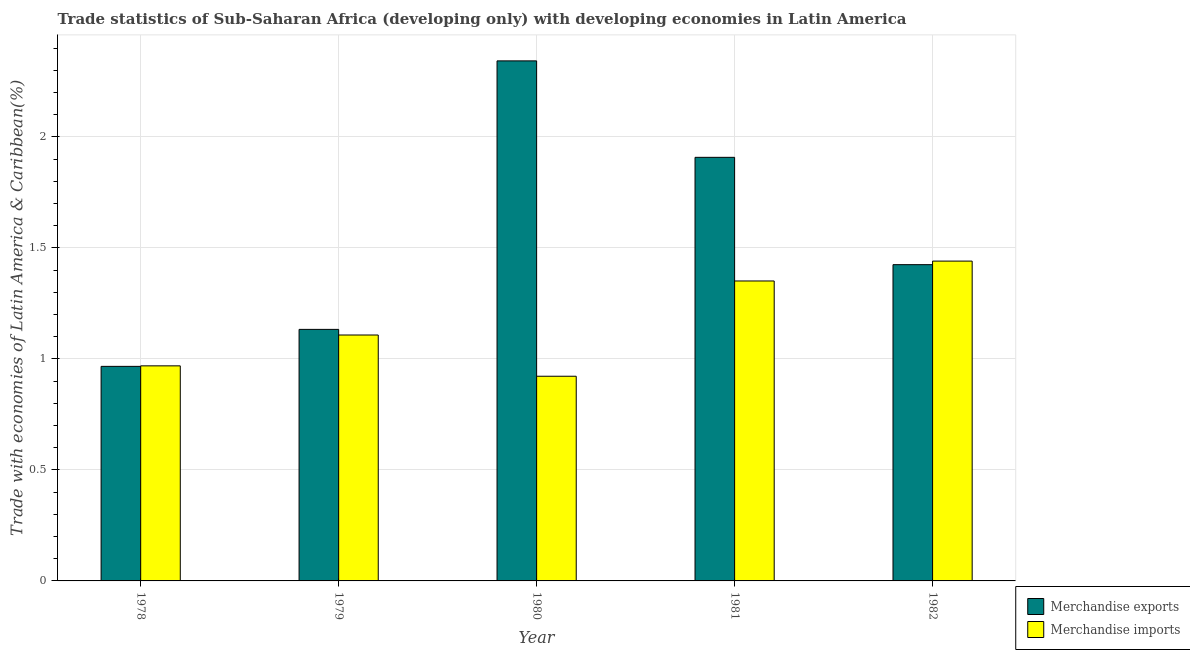How many groups of bars are there?
Give a very brief answer. 5. Are the number of bars per tick equal to the number of legend labels?
Your answer should be very brief. Yes. How many bars are there on the 1st tick from the left?
Give a very brief answer. 2. How many bars are there on the 1st tick from the right?
Your answer should be compact. 2. In how many cases, is the number of bars for a given year not equal to the number of legend labels?
Give a very brief answer. 0. What is the merchandise exports in 1981?
Ensure brevity in your answer.  1.91. Across all years, what is the maximum merchandise imports?
Offer a very short reply. 1.44. Across all years, what is the minimum merchandise imports?
Keep it short and to the point. 0.92. In which year was the merchandise exports maximum?
Your answer should be very brief. 1980. In which year was the merchandise exports minimum?
Ensure brevity in your answer.  1978. What is the total merchandise imports in the graph?
Offer a very short reply. 5.79. What is the difference between the merchandise exports in 1979 and that in 1982?
Give a very brief answer. -0.29. What is the difference between the merchandise imports in 1981 and the merchandise exports in 1978?
Give a very brief answer. 0.38. What is the average merchandise imports per year?
Your answer should be very brief. 1.16. In how many years, is the merchandise exports greater than 2 %?
Keep it short and to the point. 1. What is the ratio of the merchandise exports in 1981 to that in 1982?
Offer a very short reply. 1.34. Is the merchandise imports in 1978 less than that in 1982?
Provide a short and direct response. Yes. What is the difference between the highest and the second highest merchandise exports?
Offer a terse response. 0.43. What is the difference between the highest and the lowest merchandise exports?
Keep it short and to the point. 1.38. In how many years, is the merchandise exports greater than the average merchandise exports taken over all years?
Your response must be concise. 2. Is the sum of the merchandise imports in 1980 and 1981 greater than the maximum merchandise exports across all years?
Offer a very short reply. Yes. What does the 1st bar from the left in 1981 represents?
Provide a succinct answer. Merchandise exports. Are all the bars in the graph horizontal?
Keep it short and to the point. No. Does the graph contain any zero values?
Provide a succinct answer. No. Where does the legend appear in the graph?
Provide a succinct answer. Bottom right. How are the legend labels stacked?
Ensure brevity in your answer.  Vertical. What is the title of the graph?
Keep it short and to the point. Trade statistics of Sub-Saharan Africa (developing only) with developing economies in Latin America. Does "Age 65(male)" appear as one of the legend labels in the graph?
Your response must be concise. No. What is the label or title of the X-axis?
Make the answer very short. Year. What is the label or title of the Y-axis?
Offer a very short reply. Trade with economies of Latin America & Caribbean(%). What is the Trade with economies of Latin America & Caribbean(%) in Merchandise exports in 1978?
Offer a very short reply. 0.97. What is the Trade with economies of Latin America & Caribbean(%) of Merchandise imports in 1978?
Provide a short and direct response. 0.97. What is the Trade with economies of Latin America & Caribbean(%) of Merchandise exports in 1979?
Provide a short and direct response. 1.13. What is the Trade with economies of Latin America & Caribbean(%) in Merchandise imports in 1979?
Keep it short and to the point. 1.11. What is the Trade with economies of Latin America & Caribbean(%) in Merchandise exports in 1980?
Provide a short and direct response. 2.34. What is the Trade with economies of Latin America & Caribbean(%) in Merchandise imports in 1980?
Your answer should be compact. 0.92. What is the Trade with economies of Latin America & Caribbean(%) of Merchandise exports in 1981?
Provide a short and direct response. 1.91. What is the Trade with economies of Latin America & Caribbean(%) of Merchandise imports in 1981?
Make the answer very short. 1.35. What is the Trade with economies of Latin America & Caribbean(%) of Merchandise exports in 1982?
Your response must be concise. 1.42. What is the Trade with economies of Latin America & Caribbean(%) of Merchandise imports in 1982?
Your answer should be very brief. 1.44. Across all years, what is the maximum Trade with economies of Latin America & Caribbean(%) of Merchandise exports?
Give a very brief answer. 2.34. Across all years, what is the maximum Trade with economies of Latin America & Caribbean(%) of Merchandise imports?
Make the answer very short. 1.44. Across all years, what is the minimum Trade with economies of Latin America & Caribbean(%) in Merchandise exports?
Provide a succinct answer. 0.97. Across all years, what is the minimum Trade with economies of Latin America & Caribbean(%) in Merchandise imports?
Offer a terse response. 0.92. What is the total Trade with economies of Latin America & Caribbean(%) in Merchandise exports in the graph?
Give a very brief answer. 7.78. What is the total Trade with economies of Latin America & Caribbean(%) in Merchandise imports in the graph?
Provide a succinct answer. 5.79. What is the difference between the Trade with economies of Latin America & Caribbean(%) in Merchandise exports in 1978 and that in 1979?
Provide a short and direct response. -0.17. What is the difference between the Trade with economies of Latin America & Caribbean(%) in Merchandise imports in 1978 and that in 1979?
Provide a succinct answer. -0.14. What is the difference between the Trade with economies of Latin America & Caribbean(%) in Merchandise exports in 1978 and that in 1980?
Ensure brevity in your answer.  -1.38. What is the difference between the Trade with economies of Latin America & Caribbean(%) in Merchandise imports in 1978 and that in 1980?
Provide a succinct answer. 0.05. What is the difference between the Trade with economies of Latin America & Caribbean(%) of Merchandise exports in 1978 and that in 1981?
Your response must be concise. -0.94. What is the difference between the Trade with economies of Latin America & Caribbean(%) in Merchandise imports in 1978 and that in 1981?
Your answer should be compact. -0.38. What is the difference between the Trade with economies of Latin America & Caribbean(%) in Merchandise exports in 1978 and that in 1982?
Ensure brevity in your answer.  -0.46. What is the difference between the Trade with economies of Latin America & Caribbean(%) in Merchandise imports in 1978 and that in 1982?
Ensure brevity in your answer.  -0.47. What is the difference between the Trade with economies of Latin America & Caribbean(%) of Merchandise exports in 1979 and that in 1980?
Ensure brevity in your answer.  -1.21. What is the difference between the Trade with economies of Latin America & Caribbean(%) in Merchandise imports in 1979 and that in 1980?
Ensure brevity in your answer.  0.19. What is the difference between the Trade with economies of Latin America & Caribbean(%) in Merchandise exports in 1979 and that in 1981?
Keep it short and to the point. -0.78. What is the difference between the Trade with economies of Latin America & Caribbean(%) of Merchandise imports in 1979 and that in 1981?
Make the answer very short. -0.24. What is the difference between the Trade with economies of Latin America & Caribbean(%) in Merchandise exports in 1979 and that in 1982?
Your answer should be very brief. -0.29. What is the difference between the Trade with economies of Latin America & Caribbean(%) of Merchandise imports in 1979 and that in 1982?
Your answer should be compact. -0.33. What is the difference between the Trade with economies of Latin America & Caribbean(%) of Merchandise exports in 1980 and that in 1981?
Provide a short and direct response. 0.43. What is the difference between the Trade with economies of Latin America & Caribbean(%) in Merchandise imports in 1980 and that in 1981?
Your response must be concise. -0.43. What is the difference between the Trade with economies of Latin America & Caribbean(%) of Merchandise exports in 1980 and that in 1982?
Offer a very short reply. 0.92. What is the difference between the Trade with economies of Latin America & Caribbean(%) of Merchandise imports in 1980 and that in 1982?
Your answer should be compact. -0.52. What is the difference between the Trade with economies of Latin America & Caribbean(%) of Merchandise exports in 1981 and that in 1982?
Ensure brevity in your answer.  0.48. What is the difference between the Trade with economies of Latin America & Caribbean(%) in Merchandise imports in 1981 and that in 1982?
Make the answer very short. -0.09. What is the difference between the Trade with economies of Latin America & Caribbean(%) of Merchandise exports in 1978 and the Trade with economies of Latin America & Caribbean(%) of Merchandise imports in 1979?
Keep it short and to the point. -0.14. What is the difference between the Trade with economies of Latin America & Caribbean(%) in Merchandise exports in 1978 and the Trade with economies of Latin America & Caribbean(%) in Merchandise imports in 1980?
Provide a short and direct response. 0.04. What is the difference between the Trade with economies of Latin America & Caribbean(%) of Merchandise exports in 1978 and the Trade with economies of Latin America & Caribbean(%) of Merchandise imports in 1981?
Provide a short and direct response. -0.38. What is the difference between the Trade with economies of Latin America & Caribbean(%) in Merchandise exports in 1978 and the Trade with economies of Latin America & Caribbean(%) in Merchandise imports in 1982?
Ensure brevity in your answer.  -0.47. What is the difference between the Trade with economies of Latin America & Caribbean(%) of Merchandise exports in 1979 and the Trade with economies of Latin America & Caribbean(%) of Merchandise imports in 1980?
Provide a short and direct response. 0.21. What is the difference between the Trade with economies of Latin America & Caribbean(%) in Merchandise exports in 1979 and the Trade with economies of Latin America & Caribbean(%) in Merchandise imports in 1981?
Give a very brief answer. -0.22. What is the difference between the Trade with economies of Latin America & Caribbean(%) in Merchandise exports in 1979 and the Trade with economies of Latin America & Caribbean(%) in Merchandise imports in 1982?
Offer a very short reply. -0.31. What is the difference between the Trade with economies of Latin America & Caribbean(%) of Merchandise exports in 1980 and the Trade with economies of Latin America & Caribbean(%) of Merchandise imports in 1982?
Your answer should be compact. 0.9. What is the difference between the Trade with economies of Latin America & Caribbean(%) of Merchandise exports in 1981 and the Trade with economies of Latin America & Caribbean(%) of Merchandise imports in 1982?
Keep it short and to the point. 0.47. What is the average Trade with economies of Latin America & Caribbean(%) in Merchandise exports per year?
Your answer should be very brief. 1.56. What is the average Trade with economies of Latin America & Caribbean(%) in Merchandise imports per year?
Provide a short and direct response. 1.16. In the year 1978, what is the difference between the Trade with economies of Latin America & Caribbean(%) of Merchandise exports and Trade with economies of Latin America & Caribbean(%) of Merchandise imports?
Give a very brief answer. -0. In the year 1979, what is the difference between the Trade with economies of Latin America & Caribbean(%) of Merchandise exports and Trade with economies of Latin America & Caribbean(%) of Merchandise imports?
Provide a short and direct response. 0.03. In the year 1980, what is the difference between the Trade with economies of Latin America & Caribbean(%) of Merchandise exports and Trade with economies of Latin America & Caribbean(%) of Merchandise imports?
Ensure brevity in your answer.  1.42. In the year 1981, what is the difference between the Trade with economies of Latin America & Caribbean(%) in Merchandise exports and Trade with economies of Latin America & Caribbean(%) in Merchandise imports?
Ensure brevity in your answer.  0.56. In the year 1982, what is the difference between the Trade with economies of Latin America & Caribbean(%) of Merchandise exports and Trade with economies of Latin America & Caribbean(%) of Merchandise imports?
Your response must be concise. -0.02. What is the ratio of the Trade with economies of Latin America & Caribbean(%) of Merchandise exports in 1978 to that in 1979?
Offer a very short reply. 0.85. What is the ratio of the Trade with economies of Latin America & Caribbean(%) of Merchandise imports in 1978 to that in 1979?
Keep it short and to the point. 0.87. What is the ratio of the Trade with economies of Latin America & Caribbean(%) in Merchandise exports in 1978 to that in 1980?
Provide a succinct answer. 0.41. What is the ratio of the Trade with economies of Latin America & Caribbean(%) in Merchandise imports in 1978 to that in 1980?
Keep it short and to the point. 1.05. What is the ratio of the Trade with economies of Latin America & Caribbean(%) of Merchandise exports in 1978 to that in 1981?
Give a very brief answer. 0.51. What is the ratio of the Trade with economies of Latin America & Caribbean(%) in Merchandise imports in 1978 to that in 1981?
Your response must be concise. 0.72. What is the ratio of the Trade with economies of Latin America & Caribbean(%) in Merchandise exports in 1978 to that in 1982?
Ensure brevity in your answer.  0.68. What is the ratio of the Trade with economies of Latin America & Caribbean(%) in Merchandise imports in 1978 to that in 1982?
Offer a terse response. 0.67. What is the ratio of the Trade with economies of Latin America & Caribbean(%) in Merchandise exports in 1979 to that in 1980?
Offer a very short reply. 0.48. What is the ratio of the Trade with economies of Latin America & Caribbean(%) in Merchandise imports in 1979 to that in 1980?
Ensure brevity in your answer.  1.2. What is the ratio of the Trade with economies of Latin America & Caribbean(%) in Merchandise exports in 1979 to that in 1981?
Give a very brief answer. 0.59. What is the ratio of the Trade with economies of Latin America & Caribbean(%) of Merchandise imports in 1979 to that in 1981?
Your answer should be very brief. 0.82. What is the ratio of the Trade with economies of Latin America & Caribbean(%) of Merchandise exports in 1979 to that in 1982?
Offer a very short reply. 0.8. What is the ratio of the Trade with economies of Latin America & Caribbean(%) of Merchandise imports in 1979 to that in 1982?
Your answer should be very brief. 0.77. What is the ratio of the Trade with economies of Latin America & Caribbean(%) of Merchandise exports in 1980 to that in 1981?
Provide a succinct answer. 1.23. What is the ratio of the Trade with economies of Latin America & Caribbean(%) in Merchandise imports in 1980 to that in 1981?
Provide a succinct answer. 0.68. What is the ratio of the Trade with economies of Latin America & Caribbean(%) of Merchandise exports in 1980 to that in 1982?
Offer a very short reply. 1.64. What is the ratio of the Trade with economies of Latin America & Caribbean(%) in Merchandise imports in 1980 to that in 1982?
Your answer should be very brief. 0.64. What is the ratio of the Trade with economies of Latin America & Caribbean(%) in Merchandise exports in 1981 to that in 1982?
Ensure brevity in your answer.  1.34. What is the ratio of the Trade with economies of Latin America & Caribbean(%) in Merchandise imports in 1981 to that in 1982?
Your response must be concise. 0.94. What is the difference between the highest and the second highest Trade with economies of Latin America & Caribbean(%) in Merchandise exports?
Give a very brief answer. 0.43. What is the difference between the highest and the second highest Trade with economies of Latin America & Caribbean(%) in Merchandise imports?
Provide a short and direct response. 0.09. What is the difference between the highest and the lowest Trade with economies of Latin America & Caribbean(%) in Merchandise exports?
Your response must be concise. 1.38. What is the difference between the highest and the lowest Trade with economies of Latin America & Caribbean(%) in Merchandise imports?
Your response must be concise. 0.52. 